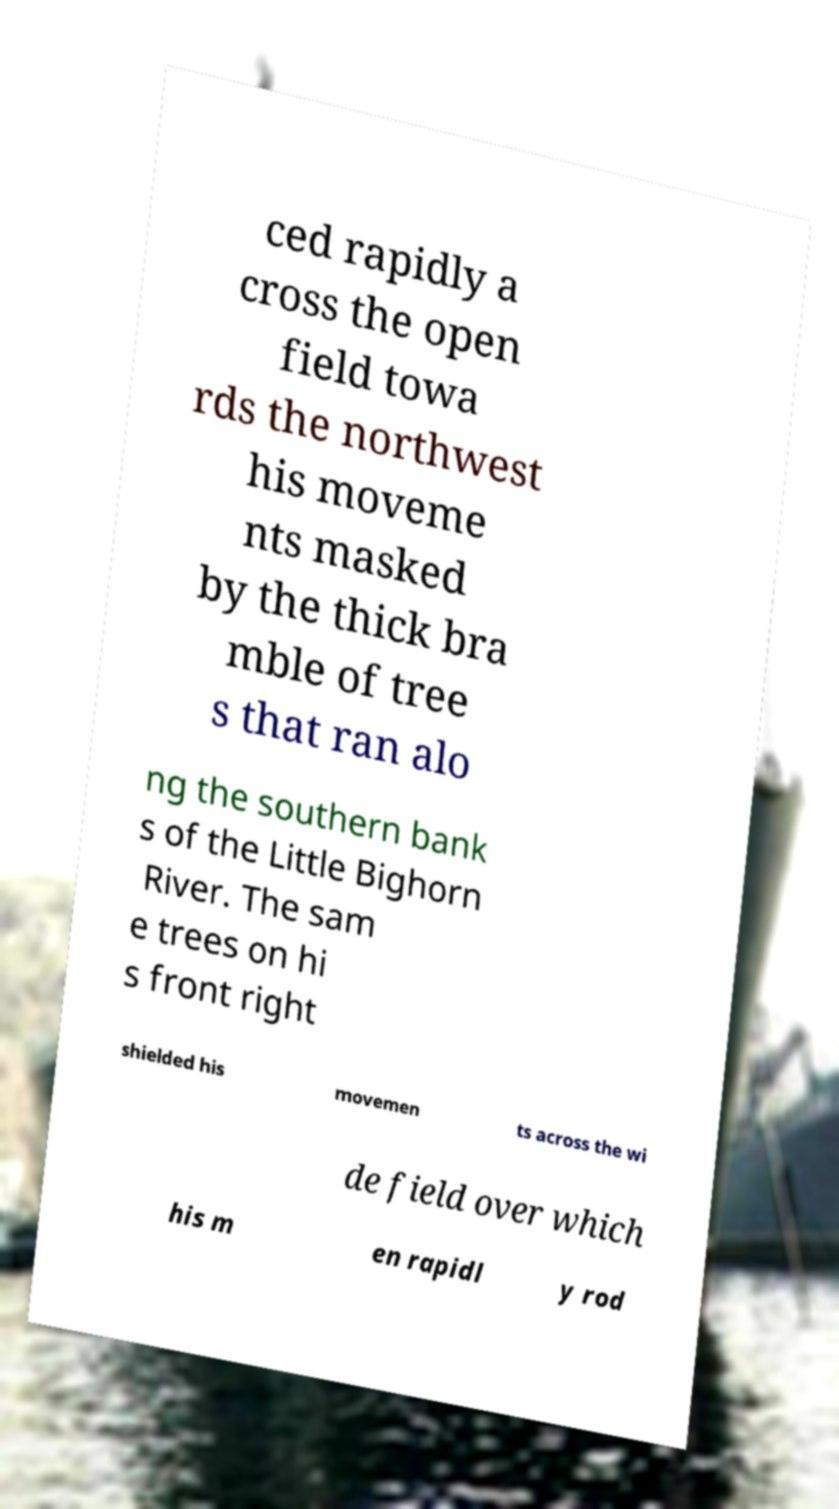There's text embedded in this image that I need extracted. Can you transcribe it verbatim? ced rapidly a cross the open field towa rds the northwest his moveme nts masked by the thick bra mble of tree s that ran alo ng the southern bank s of the Little Bighorn River. The sam e trees on hi s front right shielded his movemen ts across the wi de field over which his m en rapidl y rod 